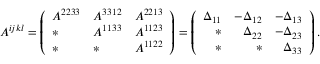<formula> <loc_0><loc_0><loc_500><loc_500>A ^ { i j k l } = \left ( \begin{array} { l l l } { A ^ { 2 2 3 3 } } & { A ^ { 3 3 1 2 } } & { A ^ { 2 2 1 3 } } \\ { * } & { A ^ { 1 1 3 3 } } & { A ^ { 1 1 2 3 } } \\ { * } & { * } & { A ^ { 1 1 2 2 } } \end{array} \right ) = \left ( \begin{array} { r r r } { \Delta _ { 1 1 } } & { - \Delta _ { 1 2 } } & { - \Delta _ { 1 3 } } \\ { * } & { \Delta _ { 2 2 } } & { - \Delta _ { 2 3 } } \\ { * } & { * } & { \Delta _ { 3 3 } } \end{array} \right ) .</formula> 